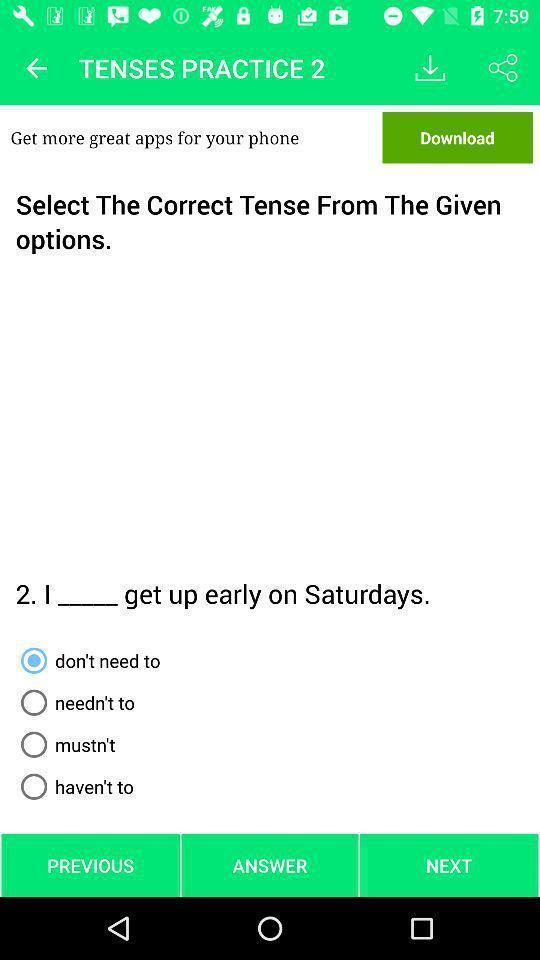Tell me about the visual elements in this screen capture. Page for selecting a tense of a tenses learning app. 